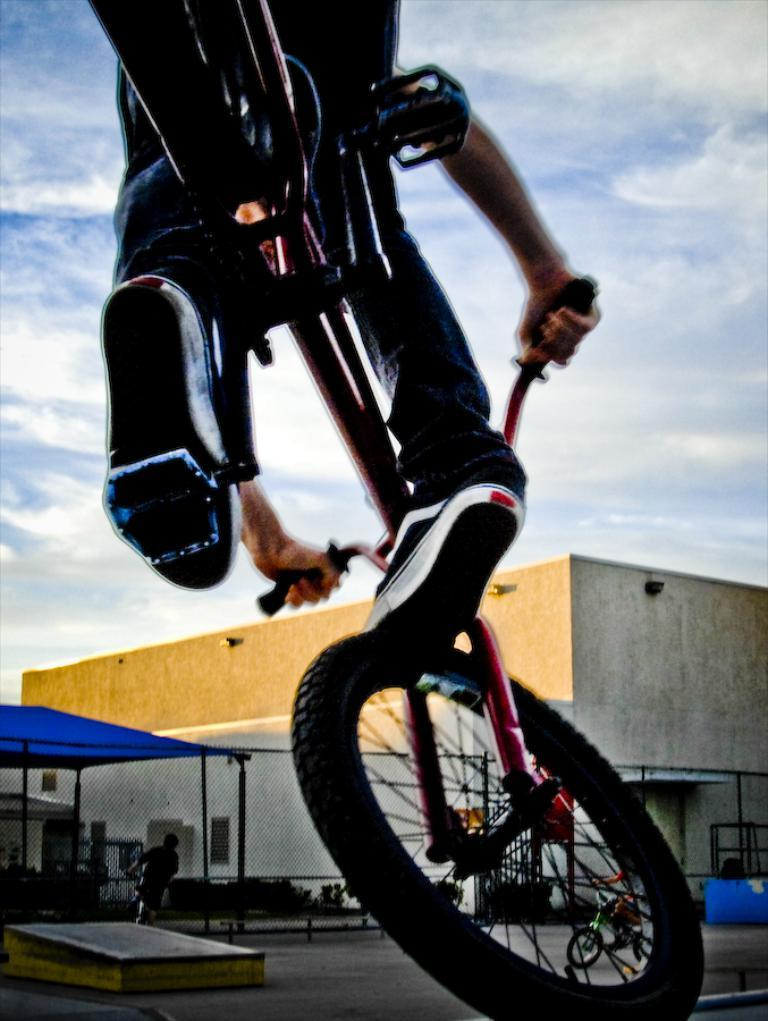What is the main subject of the image? There is a person riding a bicycle in the image. What can be seen on the left side of the image? There is a blue color tent on the left side of the image. What structure is located in the middle of the image? There appears to be a building in the middle of the image. What is visible at the top of the image? The sky is visible at the top of the image. How many horses are present in the image? There are no horses present in the image. What part of the person's body is visible while riding the bicycle? The provided facts do not mention any specific body parts of the person riding the bicycle. 